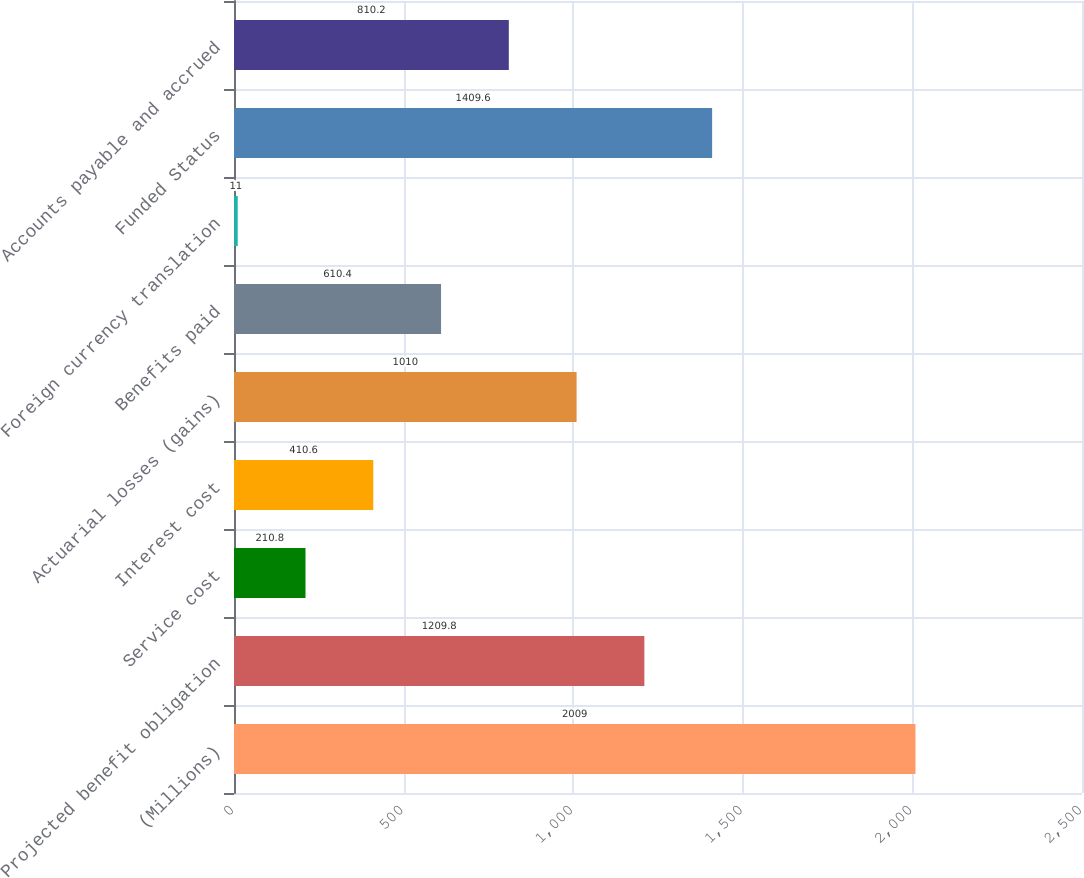<chart> <loc_0><loc_0><loc_500><loc_500><bar_chart><fcel>(Millions)<fcel>Projected benefit obligation<fcel>Service cost<fcel>Interest cost<fcel>Actuarial losses (gains)<fcel>Benefits paid<fcel>Foreign currency translation<fcel>Funded Status<fcel>Accounts payable and accrued<nl><fcel>2009<fcel>1209.8<fcel>210.8<fcel>410.6<fcel>1010<fcel>610.4<fcel>11<fcel>1409.6<fcel>810.2<nl></chart> 